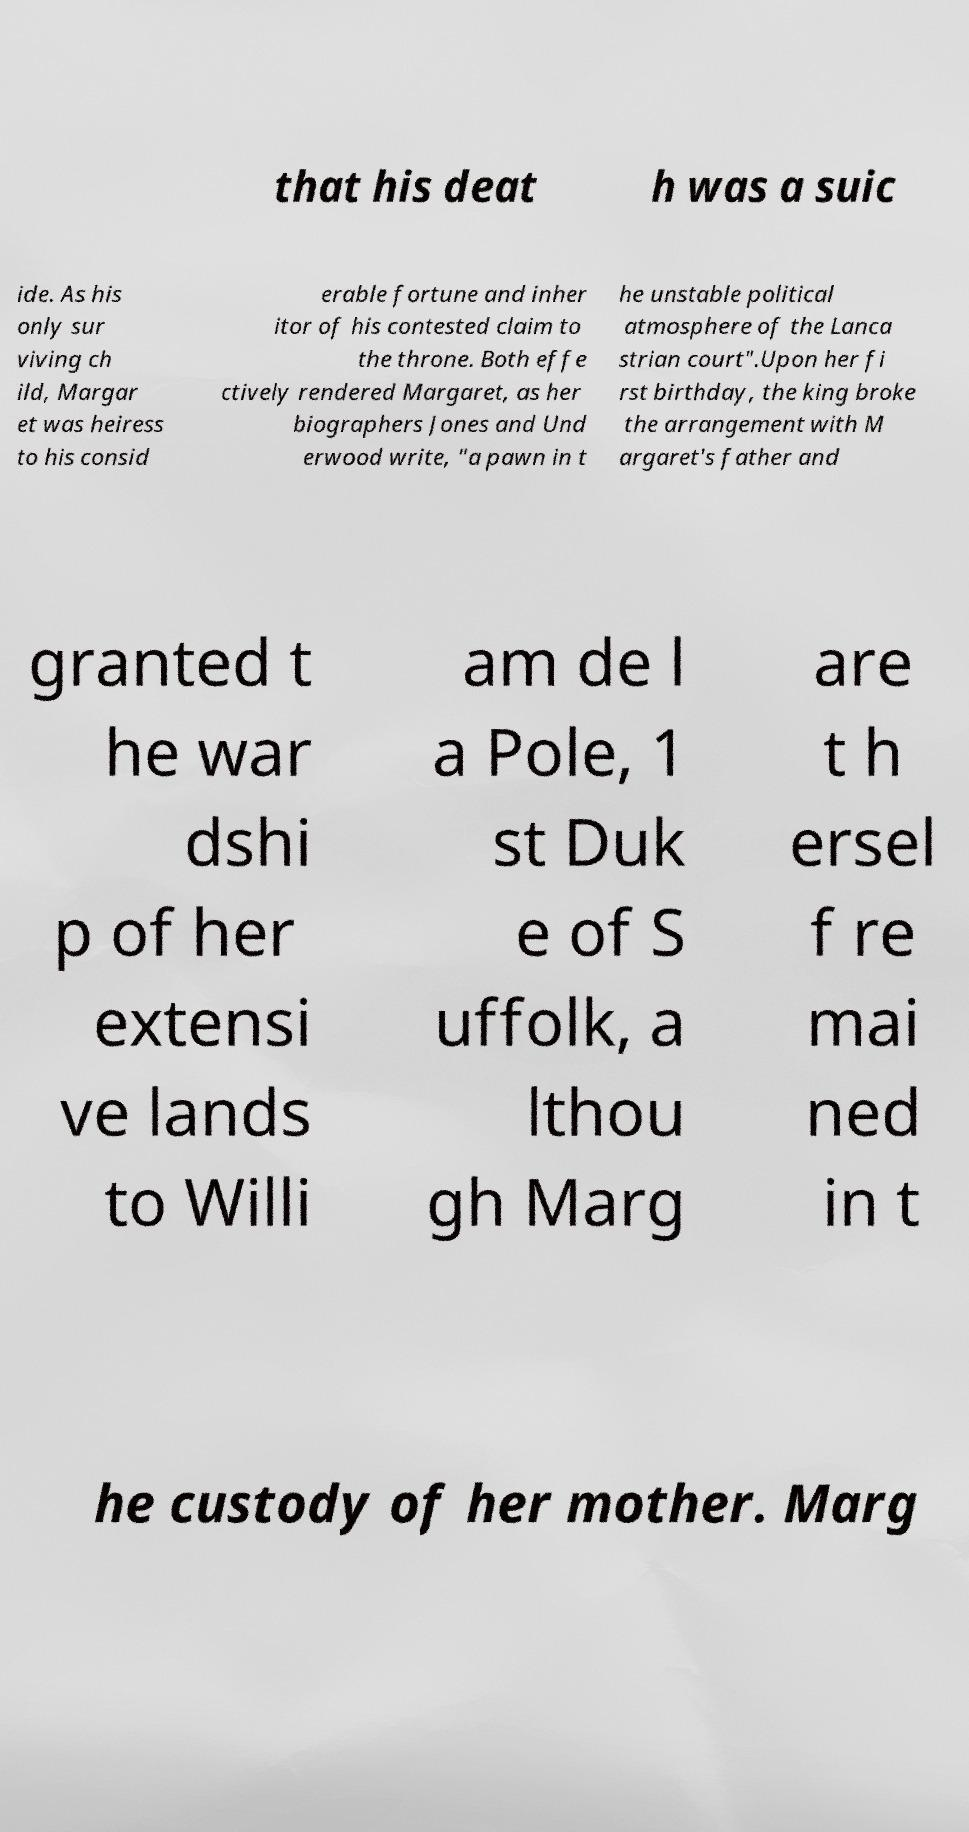Could you extract and type out the text from this image? that his deat h was a suic ide. As his only sur viving ch ild, Margar et was heiress to his consid erable fortune and inher itor of his contested claim to the throne. Both effe ctively rendered Margaret, as her biographers Jones and Und erwood write, "a pawn in t he unstable political atmosphere of the Lanca strian court".Upon her fi rst birthday, the king broke the arrangement with M argaret's father and granted t he war dshi p of her extensi ve lands to Willi am de l a Pole, 1 st Duk e of S uffolk, a lthou gh Marg are t h ersel f re mai ned in t he custody of her mother. Marg 